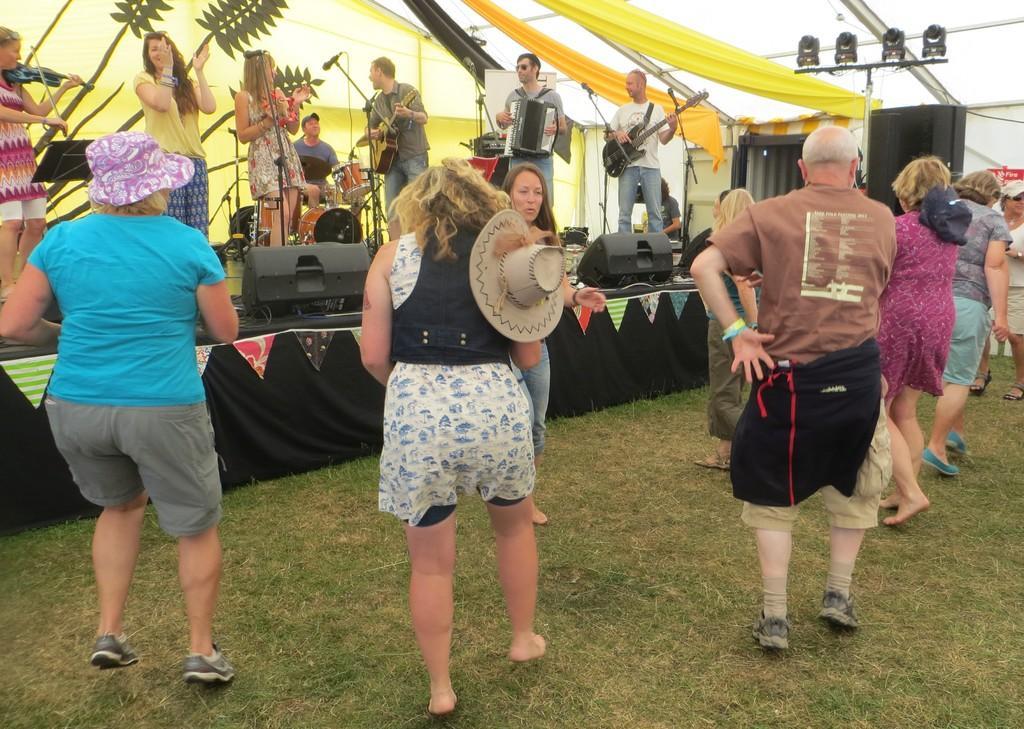Please provide a concise description of this image. In this image few persons are dancing on the grass land. Woman wearing a blue shirt is having a cap. Few persons are standing on the stage having few musical instruments, mike stands and few devices are on it. Two persons are playing guitar. A person is playing a musical instrument. Left side a woman is playing a violin. Beside there is a woman playing a violin. Beside there is a woman clapping her hands. Behind them there is a banner. Right side there is a sound speaker, beside there is a stand having few lights attached to it. 